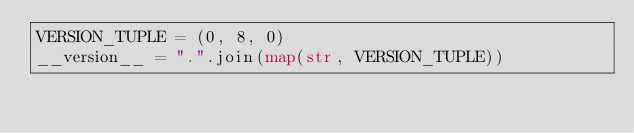Convert code to text. <code><loc_0><loc_0><loc_500><loc_500><_Python_>VERSION_TUPLE = (0, 8, 0)
__version__ = ".".join(map(str, VERSION_TUPLE))
</code> 